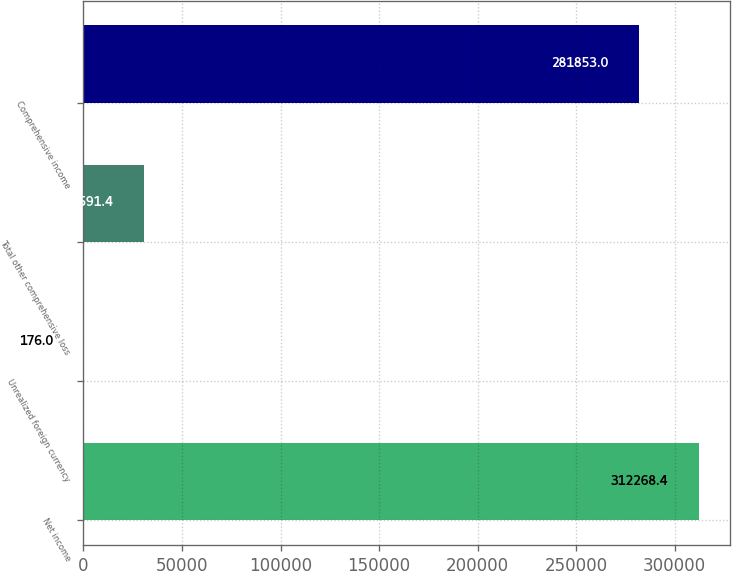<chart> <loc_0><loc_0><loc_500><loc_500><bar_chart><fcel>Net income<fcel>Unrealized foreign currency<fcel>Total other comprehensive loss<fcel>Comprehensive income<nl><fcel>312268<fcel>176<fcel>30591.4<fcel>281853<nl></chart> 